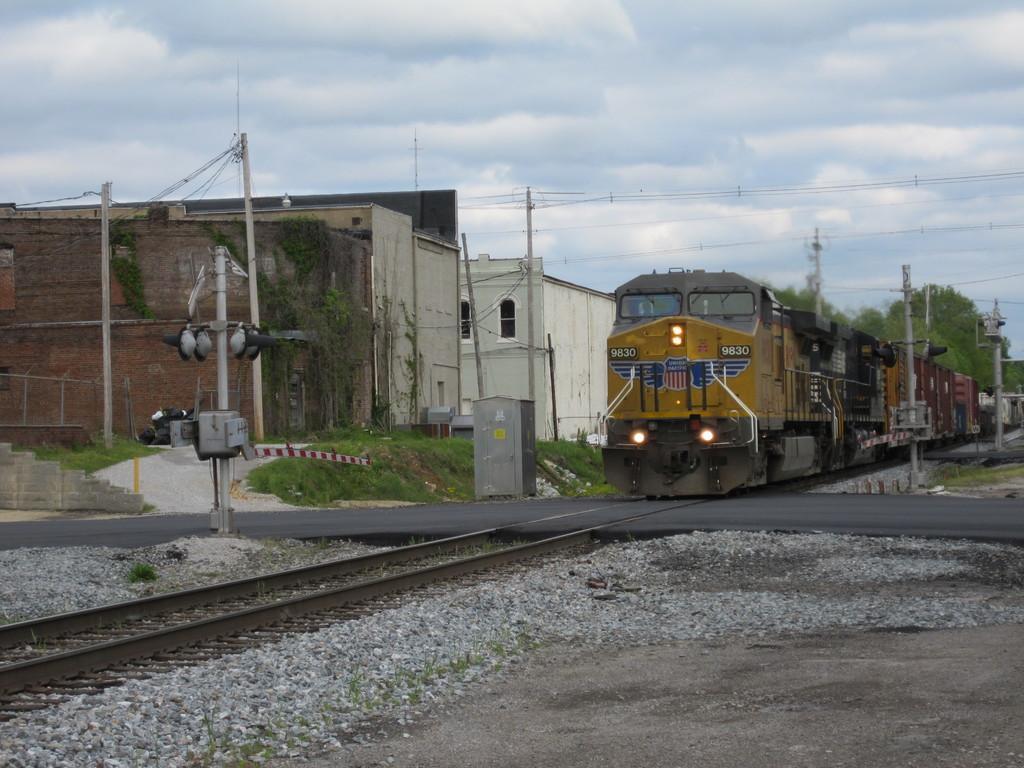How would you summarize this image in a sentence or two? This picture is clicked outside. In the foreground we can see the gravels and a railway track and we can see the poles. In the center there is a train seems to be running on the railway track. In the background we can see the poles, cables, grass, stairway, metal rods and some other objects. In the background we can see the sky which is full of clouds and we can the buildings. 